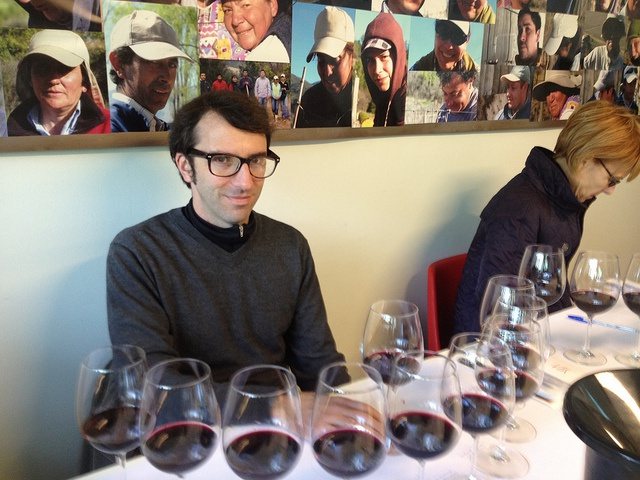Describe the objects in this image and their specific colors. I can see dining table in olive, lightgray, gray, darkgray, and black tones, people in olive, black, tan, and darkgray tones, people in olive, black, brown, and maroon tones, people in olive, black, beige, and maroon tones, and wine glass in olive, gray, black, darkgray, and lavender tones in this image. 